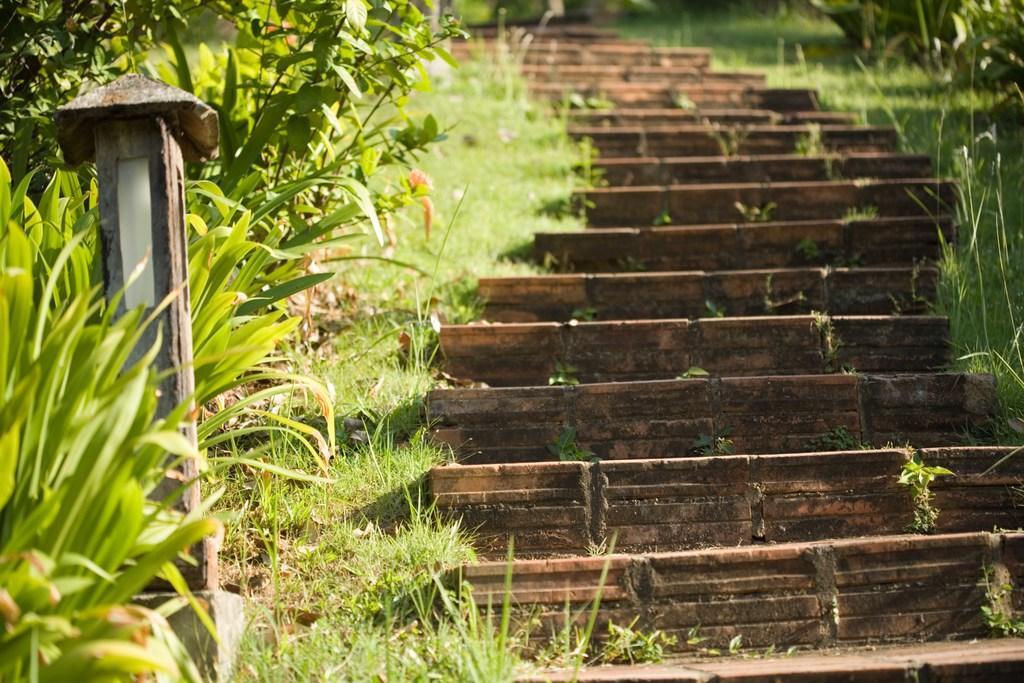How would you summarize this image in a sentence or two? In the center of the image there are stairs. On both left and right side of the image there is grass on the surface. On the left side of the image there are plants and there is a pole. 